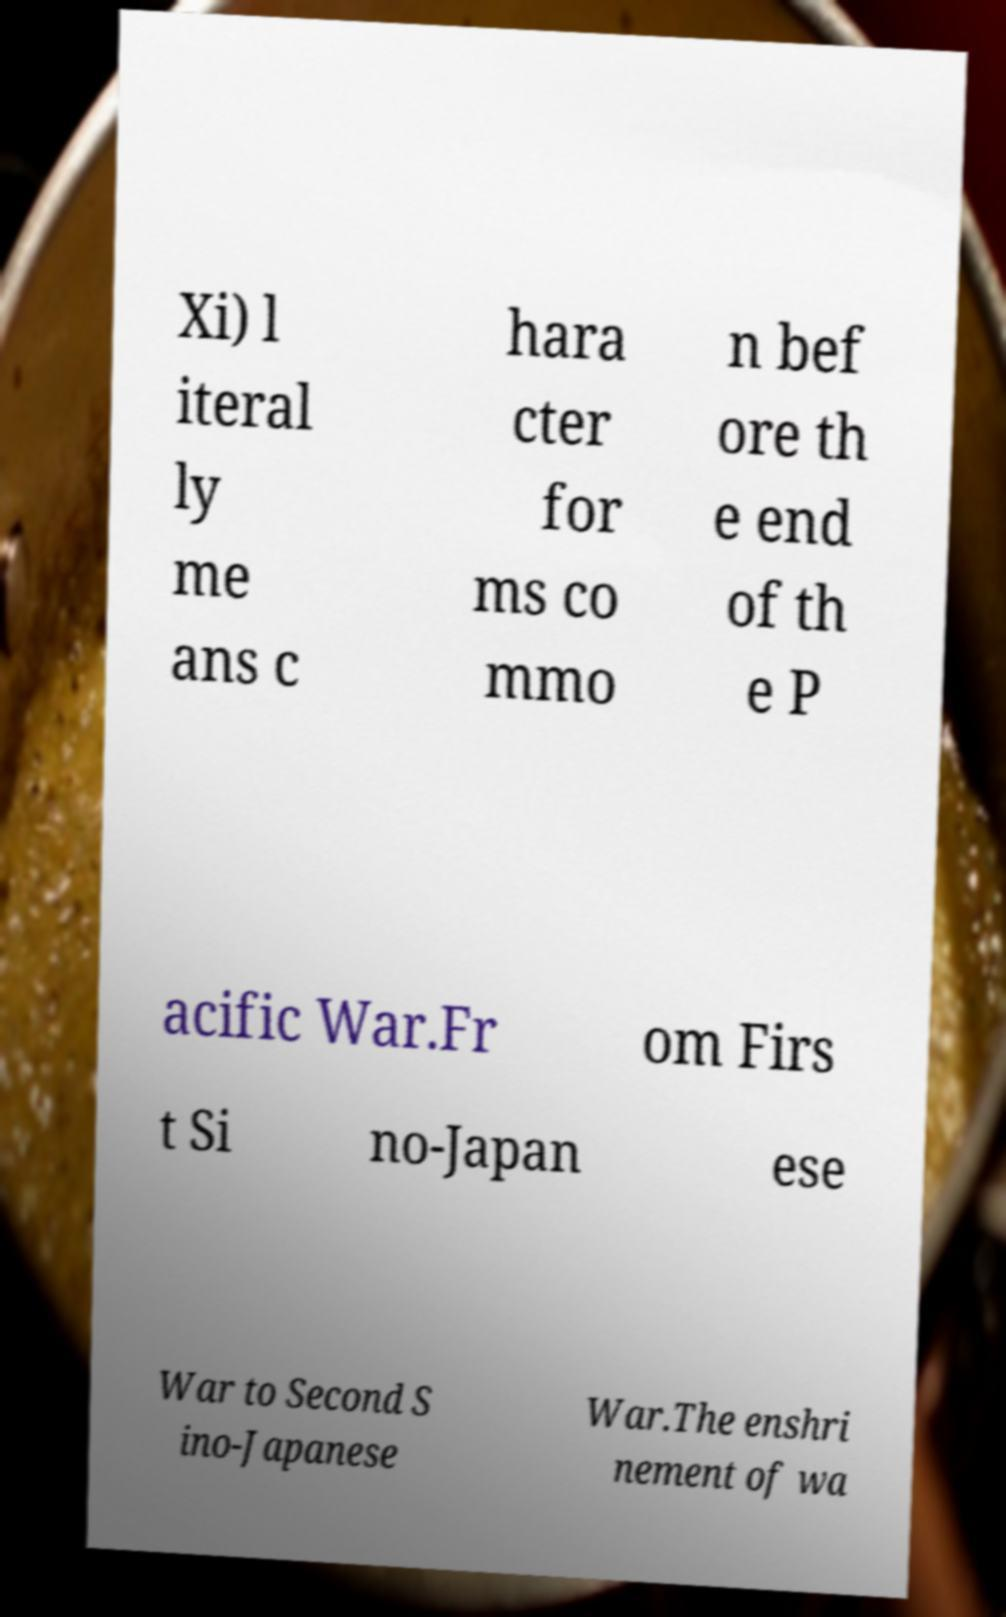Can you read and provide the text displayed in the image?This photo seems to have some interesting text. Can you extract and type it out for me? Xi) l iteral ly me ans c hara cter for ms co mmo n bef ore th e end of th e P acific War.Fr om Firs t Si no-Japan ese War to Second S ino-Japanese War.The enshri nement of wa 